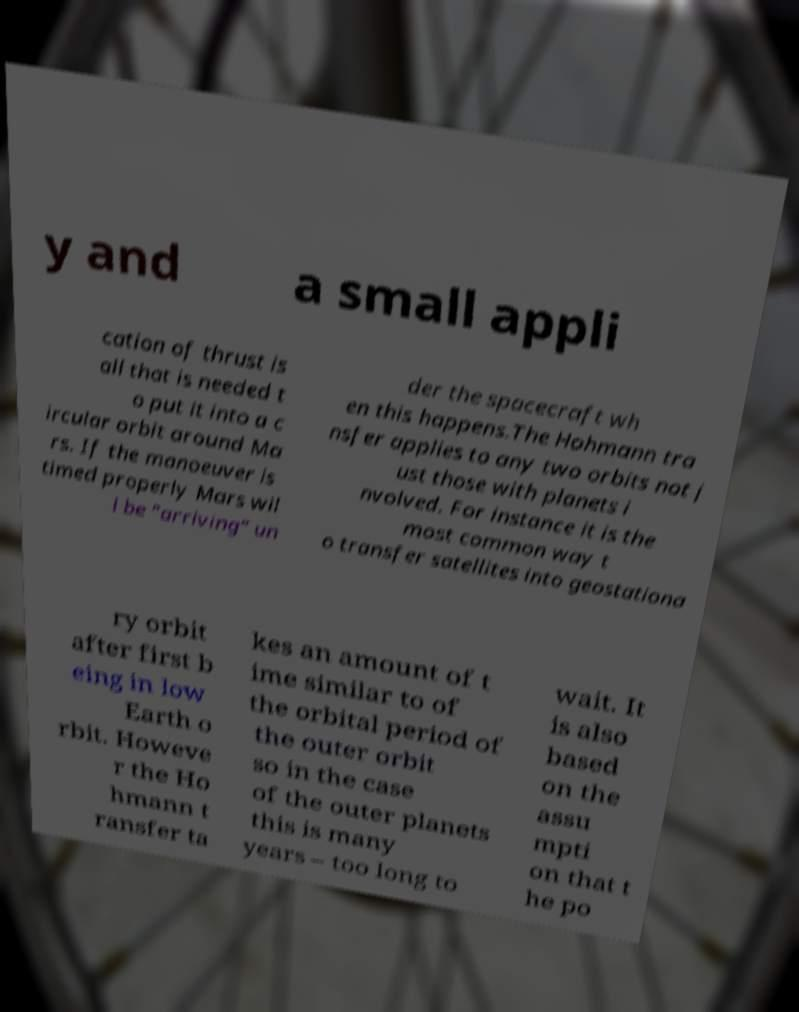Could you extract and type out the text from this image? y and a small appli cation of thrust is all that is needed t o put it into a c ircular orbit around Ma rs. If the manoeuver is timed properly Mars wil l be "arriving" un der the spacecraft wh en this happens.The Hohmann tra nsfer applies to any two orbits not j ust those with planets i nvolved. For instance it is the most common way t o transfer satellites into geostationa ry orbit after first b eing in low Earth o rbit. Howeve r the Ho hmann t ransfer ta kes an amount of t ime similar to of the orbital period of the outer orbit so in the case of the outer planets this is many years – too long to wait. It is also based on the assu mpti on that t he po 